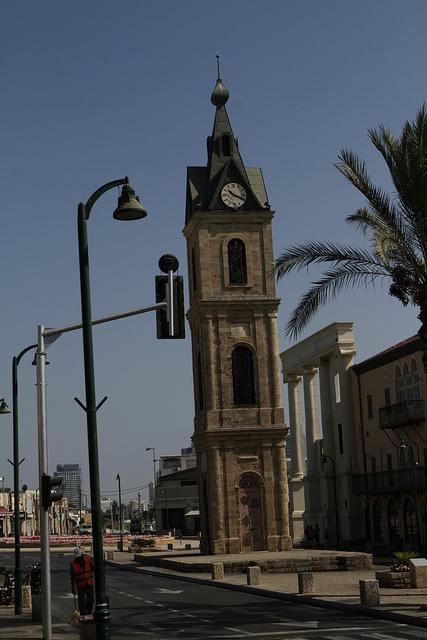What color is the door?
Give a very brief answer. Brown. How many clock faces are on the tower?
Answer briefly. 1. Is this street busy?
Concise answer only. No. What times is on the clock?
Answer briefly. 10:20. What color is the roof of the building?
Keep it brief. Brown. Is the primary object, here, ubiquitous in towns all over the world?
Be succinct. Yes. What are the things draped between the buildings?
Answer briefly. Trees. How many lights are on the light post?
Concise answer only. 1. How many light poles?
Be succinct. 2. What kind of building  is this?
Write a very short answer. Clock tower. What is in the background?
Concise answer only. Sky. What is at the bottom?
Short answer required. Street. What is in the photo?
Concise answer only. Clock tower. What time is shown on the clocks?
Short answer required. 10:20. Are there cars in the picture?
Keep it brief. No. What color are the leaves?
Keep it brief. Green. Does this building appear to be sinking?
Write a very short answer. No. What item is on top of the ledge?
Give a very brief answer. Clock. Is one of the buildings on stilts?
Concise answer only. No. How many chimneys are there?
Short answer required. 0. How many windows are on the side of the building?
Be succinct. 3. Could this be a marina?
Short answer required. No. What is the time on the clock?
Quick response, please. 10:20. How many clouds are in the sky?
Keep it brief. 0. What season is it?
Write a very short answer. Summer. What is the speed limit on this road?
Write a very short answer. Unknown. Is there traffic?
Write a very short answer. No. What time is it?
Keep it brief. 10:20. What type of tree is in the picture?
Be succinct. Palm. Is this a place of business?
Keep it brief. No. Is it sunny?
Give a very brief answer. Yes. How many towers are there?
Short answer required. 1. What time does the clock say?
Short answer required. 10:20. Is the street light as tall as the clock tower?
Quick response, please. No. What color is the ground under the fire hydrant?
Quick response, please. Black. 